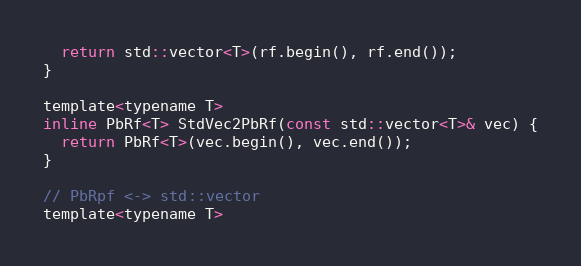<code> <loc_0><loc_0><loc_500><loc_500><_C_>  return std::vector<T>(rf.begin(), rf.end());
}

template<typename T>
inline PbRf<T> StdVec2PbRf(const std::vector<T>& vec) {
  return PbRf<T>(vec.begin(), vec.end());
}

// PbRpf <-> std::vector
template<typename T></code> 